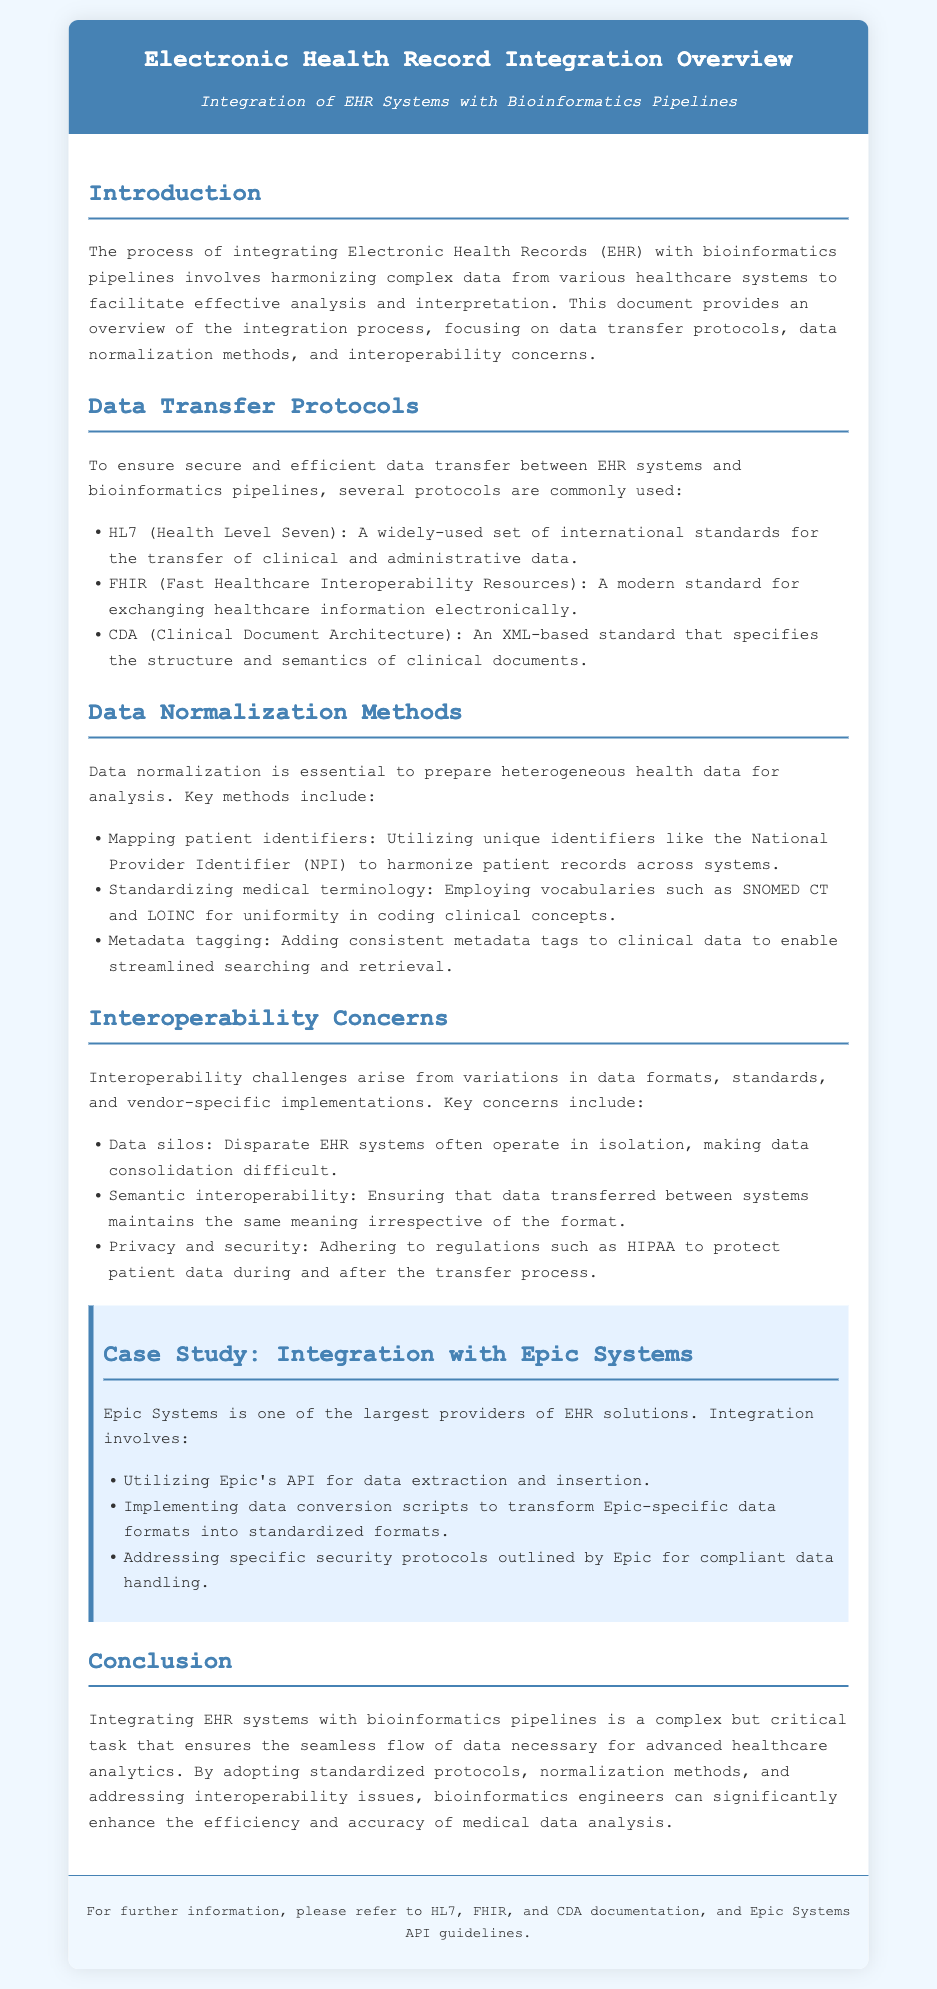What is the title of the document? The title is the primary heading of the document, which conveys the main subject.
Answer: Electronic Health Record Integration Overview What standard is widely used for the transfer of clinical and administrative data? This question asks for a specific standard mentioned in the document related to data transfer.
Answer: HL7 Which protocol is a modern standard for exchanging healthcare information? The document lists several protocols, and this one is noted for its modern approach.
Answer: FHIR Name one medical terminology vocabulary used for standardization. The document provides examples of vocabularies for uniformity, asking for one such vocabulary.
Answer: SNOMED CT What is a key interoperability concern related to EHR systems? The question seeks a specific challenge highlighted in the document regarding EHR system integration.
Answer: Data silos According to the case study, with which EHR solution does the integration involve utilizing an API? This question refers to the specific case study mentioned in the document highlighting a particular EHR provider.
Answer: Epic Systems What is the primary purpose of data normalization methods? This question inquires about the goal of the methods discussed in the document.
Answer: Prepare heterogeneous health data for analysis What does CDA stand for in the context of data transfer protocols? This abbreviation is mentioned in the document, referring to a specific standard.
Answer: Clinical Document Architecture What regulation must be adhered to for protecting patient data? This question relates to legal requirements highlighted in the interoperability concerns section.
Answer: HIPAA 